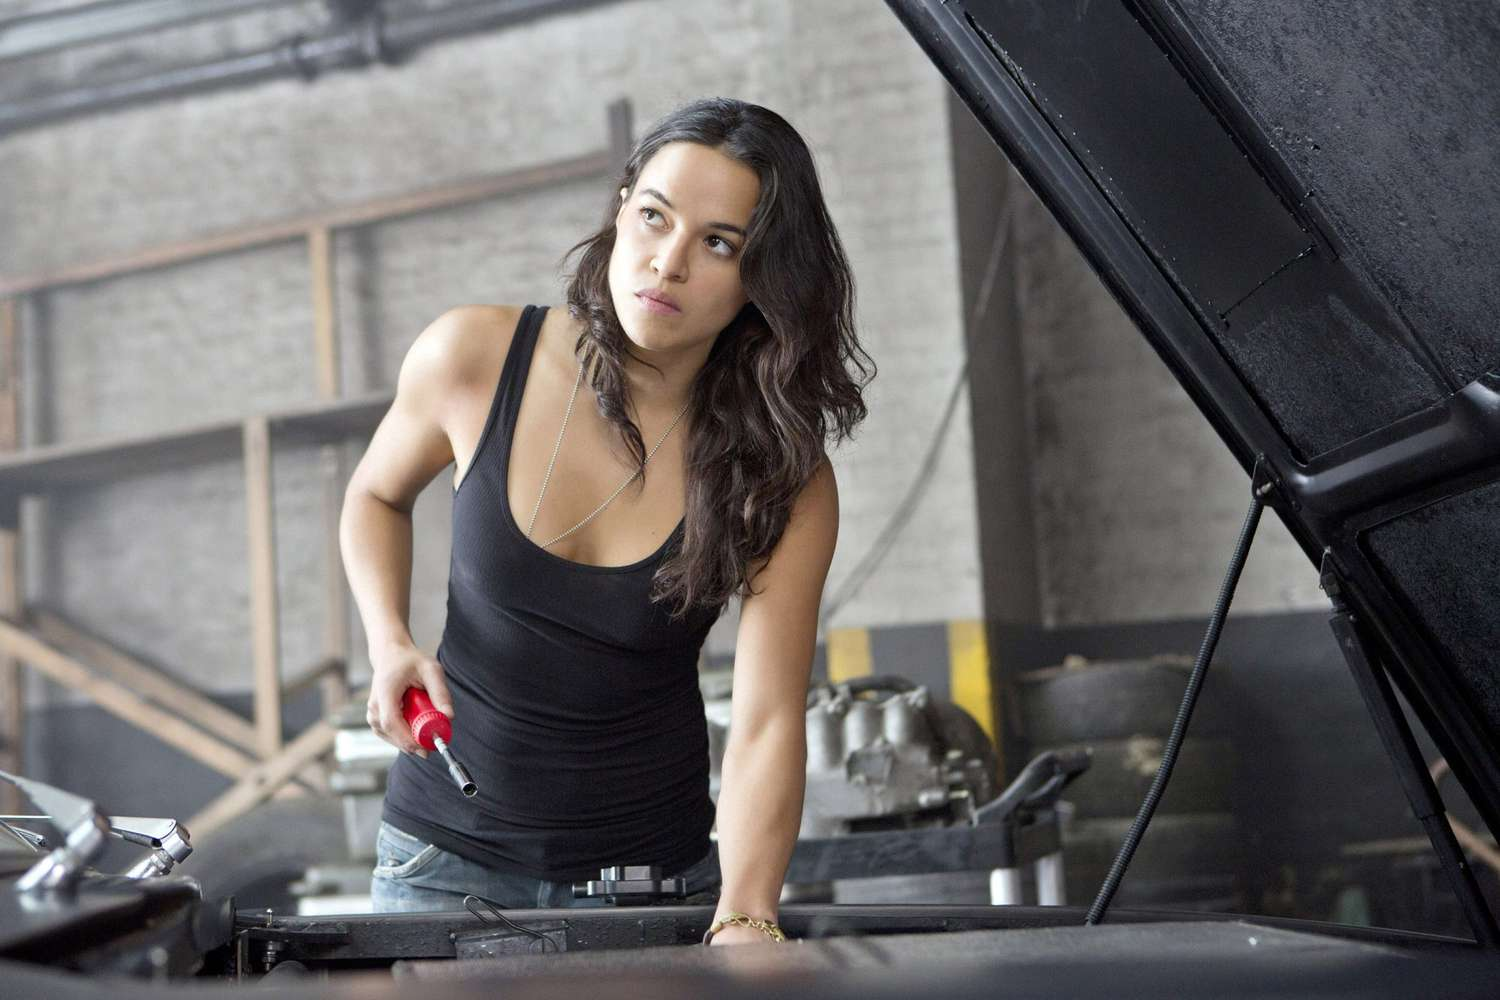Describe the setting where the automotive repair is taking place. The setting of the automotive repair is a basic garage with a gritty, utilitarian feel. The background shows a concrete brick wall with a wooden frame structure, possibly for storage. There are some tires and car parts scattered around, adding to the authentic garage atmosphere. The lighting is natural, streaming through unseen windows, accentuating the hard work and focus of the woman as she works on the car. What might the woman be thinking about as she works on the car? As the woman works on the car, her mind might be deeply focused on diagnosing and fixing the issue at hand. She could be thinking about the satisfaction of solving mechanical problems, the next steps in the repair process, and ensuring that the vehicle is in top condition. She might also be reflecting on personal goals or challenges related to her work in automotive repair, perhaps even recalling past experiences that enhance her expertise. Imagine a creative scenario where the car she is working on plays a pivotal role in a grand adventure. In an imaginative twist, the car she is working on isn't just an ordinary vehicle—it's a prototype for a top-secret, high-tech racing car designed for an underground competition. Once repaired, it is capable of lightning speeds and advanced maneuvers that can only be achieved with her expertise. As she tightens the final bolt, she's unaware that this car will soon be her key to unraveling a conspiracy that threatens the world of motorsport. She will be thrust into a thrilling adventure, filled with high-speed chases, undercover operations, and a race against time to stop a powerful antagonist from rigging the competition and seizing control of global racing events. 